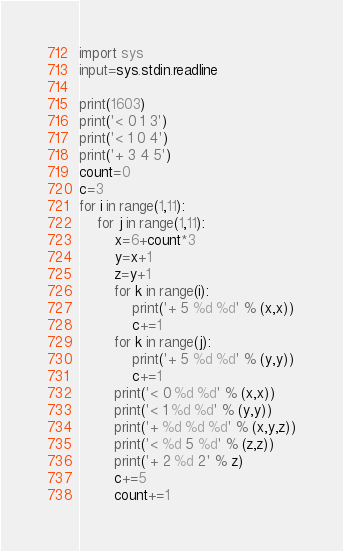<code> <loc_0><loc_0><loc_500><loc_500><_Python_>import sys
input=sys.stdin.readline

print(1603)
print('< 0 1 3')
print('< 1 0 4')
print('+ 3 4 5')
count=0
c=3
for i in range(1,11):
    for j in range(1,11):
        x=6+count*3
        y=x+1
        z=y+1
        for k in range(i):
            print('+ 5 %d %d' % (x,x))
            c+=1
        for k in range(j):
            print('+ 5 %d %d' % (y,y))
            c+=1
        print('< 0 %d %d' % (x,x))
        print('< 1 %d %d' % (y,y))
        print('+ %d %d %d' % (x,y,z))
        print('< %d 5 %d' % (z,z))
        print('+ 2 %d 2' % z)
        c+=5
        count+=1</code> 